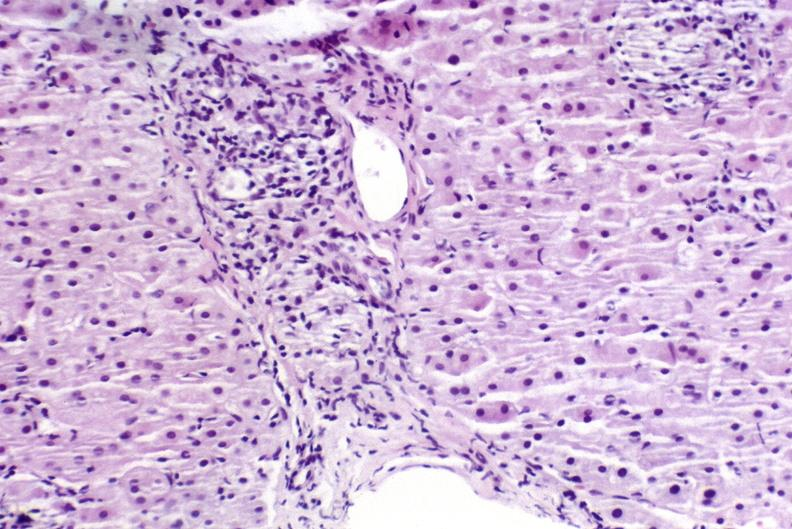does mesothelioma show sarcoid?
Answer the question using a single word or phrase. No 